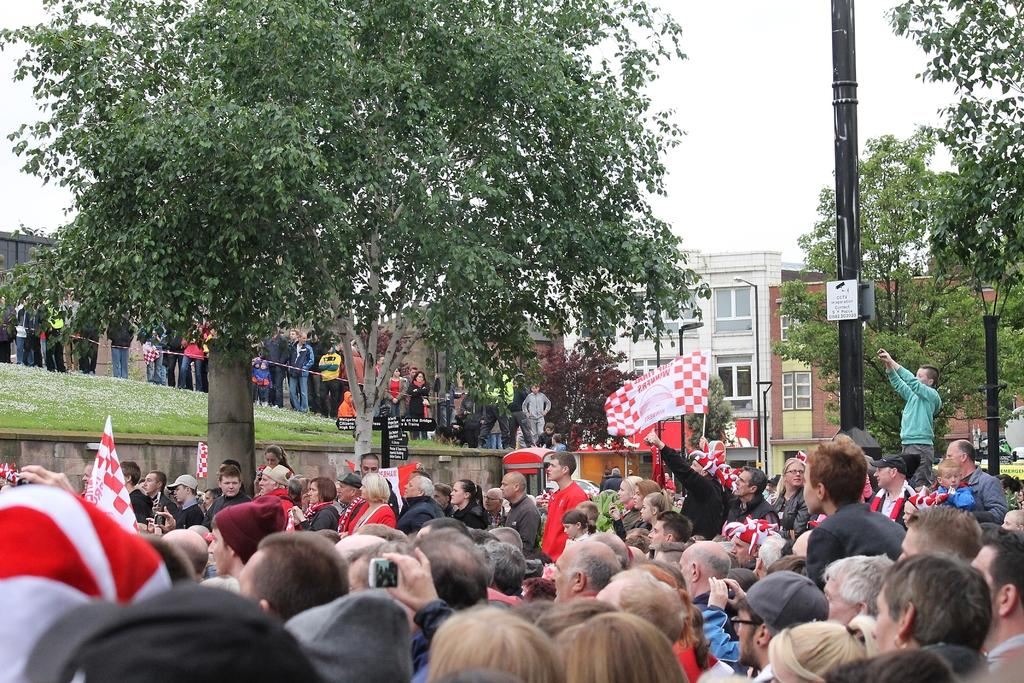What is the main subject of the image? The main subject of the image is a crowd. What are some people in the crowd doing? Some people in the crowd are holding flags. What is the landscape like in the image? The land is covered with grass, and there are trees present. Can you describe the building in the image? There is a building with windows in the image, and there is a light pole in front of it. How does the crowd get the attention of the fact in the image? There is no "fact" present in the image; it features a crowd, people holding flags, a grass-covered landscape, a building with windows, and trees. 